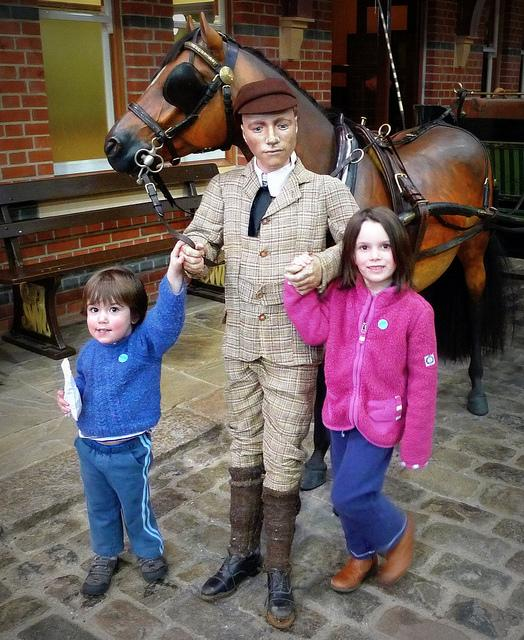What type of material makes up a majority of the construction in the area?

Choices:
A) stone
B) steel
C) wood
D) mud stone 